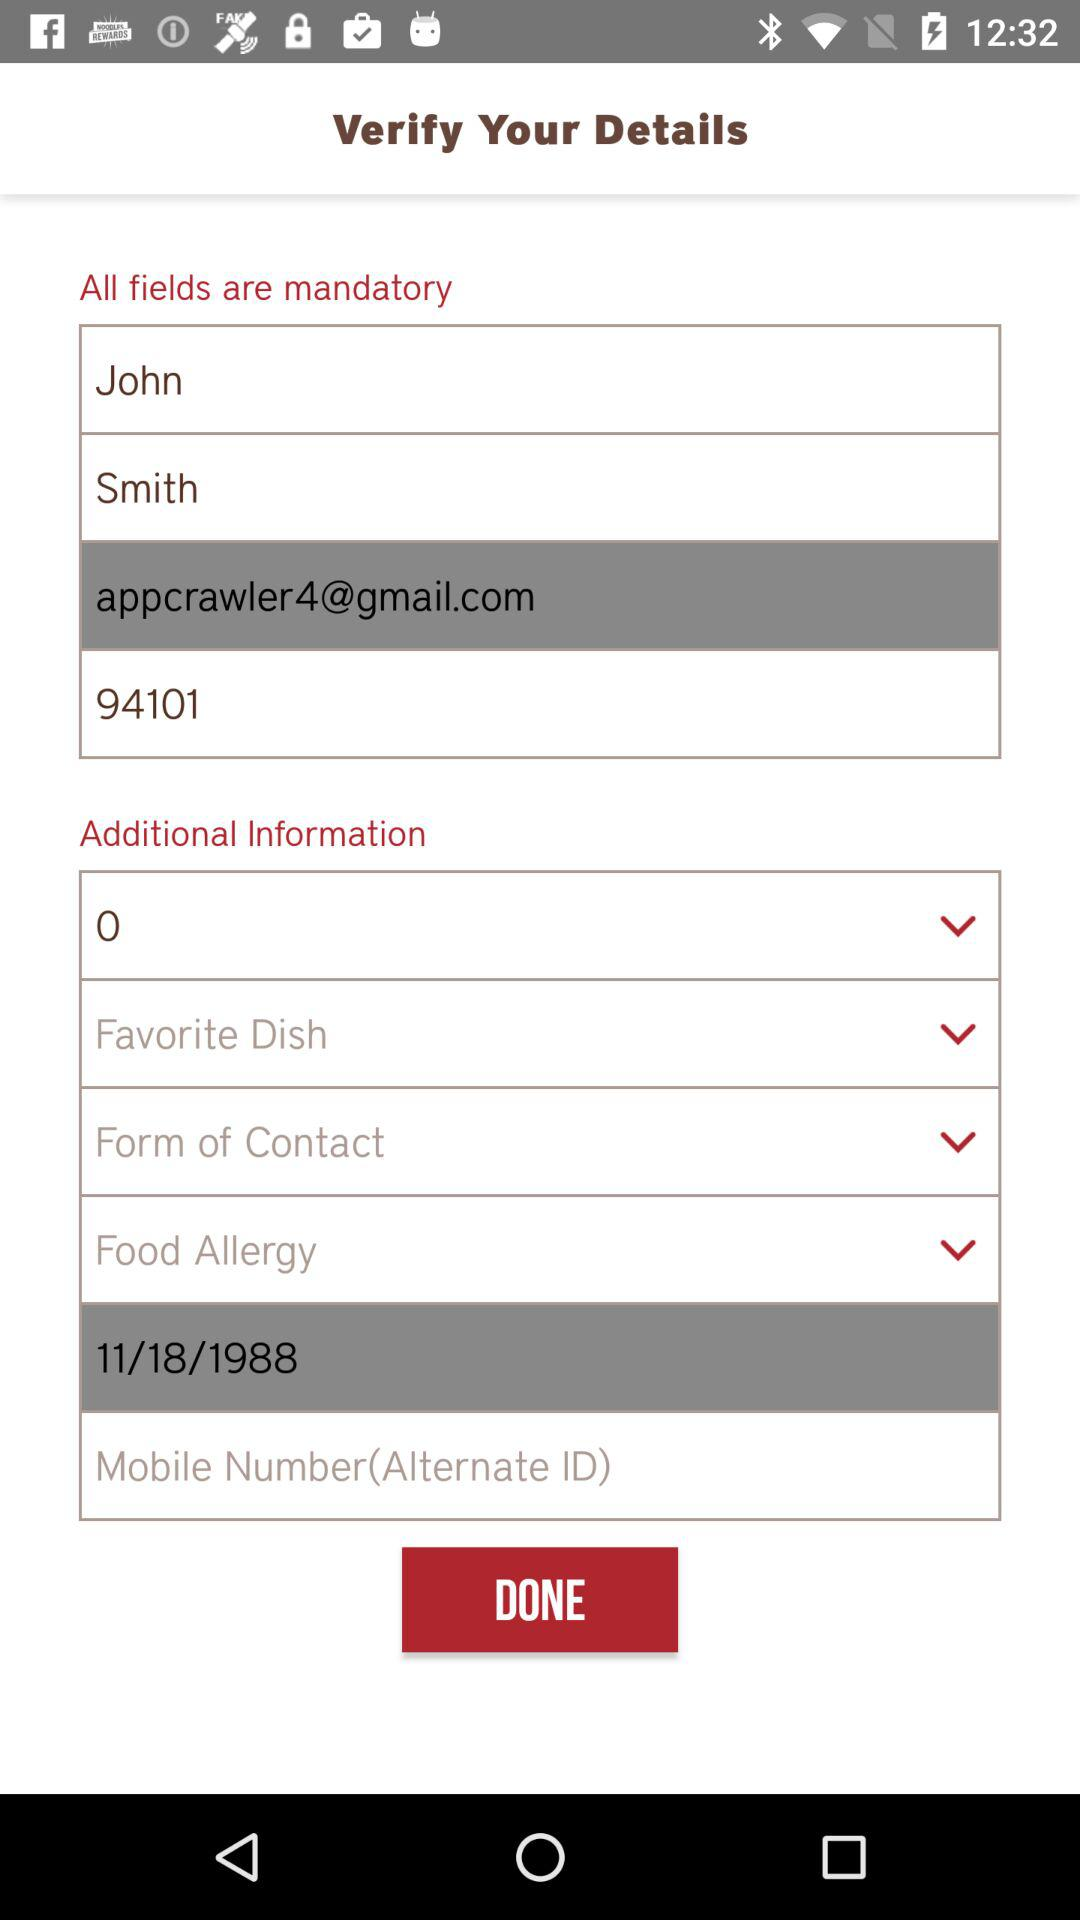What is the email address? The email address is appcrawler4@gmail.com. 